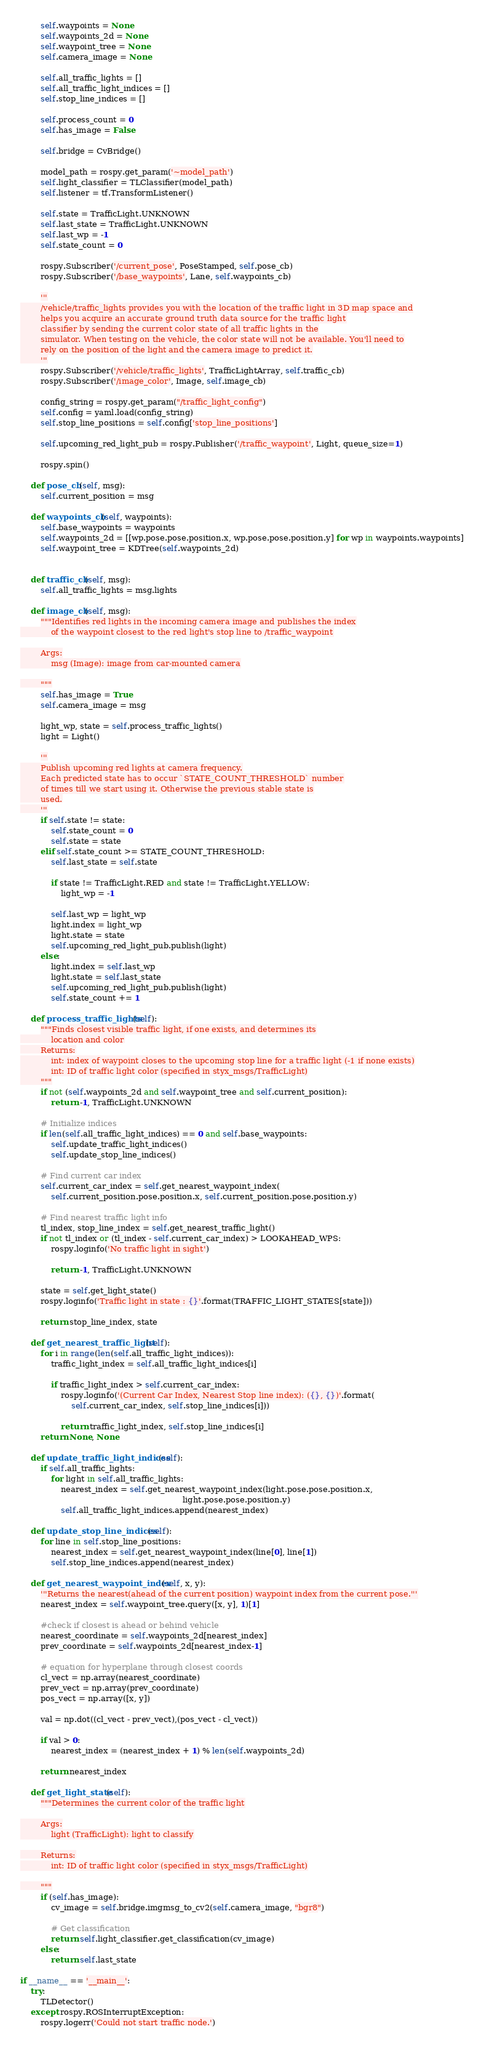<code> <loc_0><loc_0><loc_500><loc_500><_Python_>        self.waypoints = None
        self.waypoints_2d = None
        self.waypoint_tree = None
        self.camera_image = None        

        self.all_traffic_lights = []
        self.all_traffic_light_indices = []
        self.stop_line_indices = []

        self.process_count = 0
        self.has_image = False

        self.bridge = CvBridge()

        model_path = rospy.get_param('~model_path')
        self.light_classifier = TLClassifier(model_path)
        self.listener = tf.TransformListener()
        
        self.state = TrafficLight.UNKNOWN
        self.last_state = TrafficLight.UNKNOWN
        self.last_wp = -1
        self.state_count = 0 

        rospy.Subscriber('/current_pose', PoseStamped, self.pose_cb)
        rospy.Subscriber('/base_waypoints', Lane, self.waypoints_cb)

        '''
        /vehicle/traffic_lights provides you with the location of the traffic light in 3D map space and
        helps you acquire an accurate ground truth data source for the traffic light
        classifier by sending the current color state of all traffic lights in the
        simulator. When testing on the vehicle, the color state will not be available. You'll need to
        rely on the position of the light and the camera image to predict it.
        '''
        rospy.Subscriber('/vehicle/traffic_lights', TrafficLightArray, self.traffic_cb)
        rospy.Subscriber('/image_color', Image, self.image_cb)

        config_string = rospy.get_param("/traffic_light_config")
        self.config = yaml.load(config_string)
        self.stop_line_positions = self.config['stop_line_positions']

        self.upcoming_red_light_pub = rospy.Publisher('/traffic_waypoint', Light, queue_size=1)

        rospy.spin()

    def pose_cb(self, msg):
        self.current_position = msg

    def waypoints_cb(self, waypoints):
        self.base_waypoints = waypoints
        self.waypoints_2d = [[wp.pose.pose.position.x, wp.pose.pose.position.y] for wp in waypoints.waypoints]
        self.waypoint_tree = KDTree(self.waypoints_2d)


    def traffic_cb(self, msg):
        self.all_traffic_lights = msg.lights

    def image_cb(self, msg):
        """Identifies red lights in the incoming camera image and publishes the index
            of the waypoint closest to the red light's stop line to /traffic_waypoint

        Args:
            msg (Image): image from car-mounted camera

        """
        self.has_image = True
        self.camera_image = msg
        
        light_wp, state = self.process_traffic_lights()
        light = Light()
 
        '''
        Publish upcoming red lights at camera frequency.
        Each predicted state has to occur `STATE_COUNT_THRESHOLD` number
        of times till we start using it. Otherwise the previous stable state is
        used.
        '''
        if self.state != state:
            self.state_count = 0
            self.state = state
        elif self.state_count >= STATE_COUNT_THRESHOLD:
            self.last_state = self.state
            
            if state != TrafficLight.RED and state != TrafficLight.YELLOW:
                light_wp = -1

            self.last_wp = light_wp	    
            light.index = light_wp
            light.state = state 
            self.upcoming_red_light_pub.publish(light)
        else:
            light.index = self.last_wp
            light.state = self.last_state 
            self.upcoming_red_light_pub.publish(light)
            self.state_count += 1

    def process_traffic_lights(self):
        """Finds closest visible traffic light, if one exists, and determines its
            location and color
        Returns:
            int: index of waypoint closes to the upcoming stop line for a traffic light (-1 if none exists)
            int: ID of traffic light color (specified in styx_msgs/TrafficLight)
        """        
        if not (self.waypoints_2d and self.waypoint_tree and self.current_position):
            return -1, TrafficLight.UNKNOWN

        # Initialize indices
        if len(self.all_traffic_light_indices) == 0 and self.base_waypoints:
            self.update_traffic_light_indices()
            self.update_stop_line_indices()

        # Find current car index
        self.current_car_index = self.get_nearest_waypoint_index(
            self.current_position.pose.position.x, self.current_position.pose.position.y)
        
        # Find nearest traffic light info
        tl_index, stop_line_index = self.get_nearest_traffic_light()        
        if not tl_index or (tl_index - self.current_car_index) > LOOKAHEAD_WPS:
            rospy.loginfo('No traffic light in sight')

            return -1, TrafficLight.UNKNOWN

        state = self.get_light_state()
        rospy.loginfo('Traffic light in state : {}'.format(TRAFFIC_LIGHT_STATES[state]))
        
        return stop_line_index, state

    def get_nearest_traffic_light(self):
        for i in range(len(self.all_traffic_light_indices)):
            traffic_light_index = self.all_traffic_light_indices[i]

            if traffic_light_index > self.current_car_index:
                rospy.loginfo('(Current Car Index, Nearest Stop line index): ({}, {})'.format(
                    self.current_car_index, self.stop_line_indices[i]))
                
                return traffic_light_index, self.stop_line_indices[i]
        return None, None

    def update_traffic_light_indices(self):
        if self.all_traffic_lights:
            for light in self.all_traffic_lights:
                nearest_index = self.get_nearest_waypoint_index(light.pose.pose.position.x, 
                                                                light.pose.pose.position.y)
                self.all_traffic_light_indices.append(nearest_index)

    def update_stop_line_indices(self):
        for line in self.stop_line_positions:            
            nearest_index = self.get_nearest_waypoint_index(line[0], line[1])
            self.stop_line_indices.append(nearest_index)

    def get_nearest_waypoint_index(self, x, y):
        '''Returns the nearest(ahead of the current position) waypoint index from the current pose.'''
        nearest_index = self.waypoint_tree.query([x, y], 1)[1]

        #check if closest is ahead or behind vehicle
        nearest_coordinate = self.waypoints_2d[nearest_index]
        prev_coordinate = self.waypoints_2d[nearest_index-1]

        # equation for hyperplane through closest coords
        cl_vect = np.array(nearest_coordinate)
        prev_vect = np.array(prev_coordinate)
        pos_vect = np.array([x, y])

        val = np.dot((cl_vect - prev_vect),(pos_vect - cl_vect))

        if val > 0:
            nearest_index = (nearest_index + 1) % len(self.waypoints_2d)

        return nearest_index

    def get_light_state(self):
        """Determines the current color of the traffic light

        Args:
            light (TrafficLight): light to classify

        Returns:
            int: ID of traffic light color (specified in styx_msgs/TrafficLight)

        """
        if (self.has_image):
            cv_image = self.bridge.imgmsg_to_cv2(self.camera_image, "bgr8")

            # Get classification
            return self.light_classifier.get_classification(cv_image)
        else:
            return self.last_state

if __name__ == '__main__':
    try:
        TLDetector()
    except rospy.ROSInterruptException:
        rospy.logerr('Could not start traffic node.')
</code> 